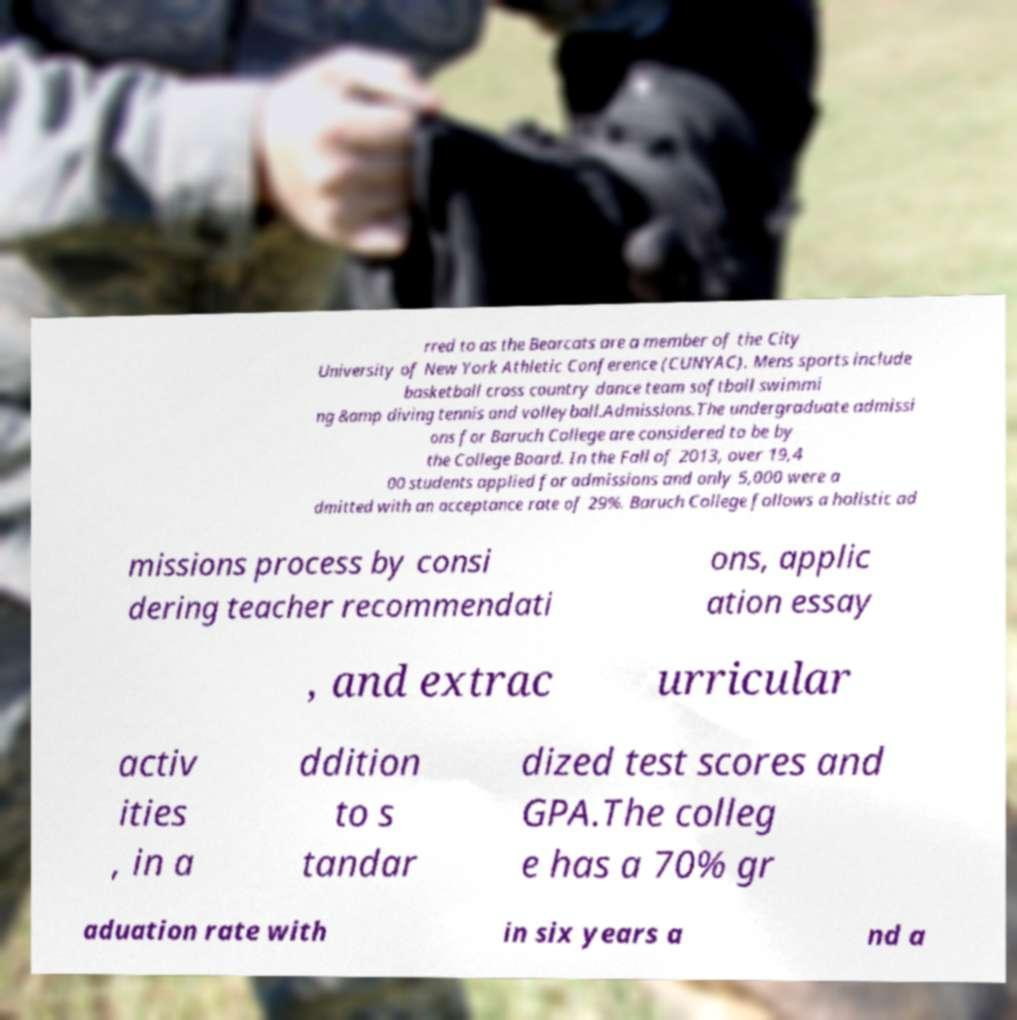What messages or text are displayed in this image? I need them in a readable, typed format. rred to as the Bearcats are a member of the City University of New York Athletic Conference (CUNYAC). Mens sports include basketball cross country dance team softball swimmi ng &amp diving tennis and volleyball.Admissions.The undergraduate admissi ons for Baruch College are considered to be by the College Board. In the Fall of 2013, over 19,4 00 students applied for admissions and only 5,000 were a dmitted with an acceptance rate of 29%. Baruch College follows a holistic ad missions process by consi dering teacher recommendati ons, applic ation essay , and extrac urricular activ ities , in a ddition to s tandar dized test scores and GPA.The colleg e has a 70% gr aduation rate with in six years a nd a 